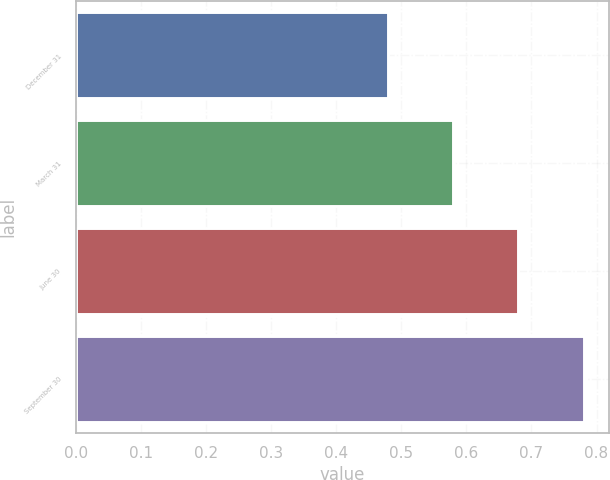Convert chart to OTSL. <chart><loc_0><loc_0><loc_500><loc_500><bar_chart><fcel>December 31<fcel>March 31<fcel>June 30<fcel>September 30<nl><fcel>0.48<fcel>0.58<fcel>0.68<fcel>0.78<nl></chart> 